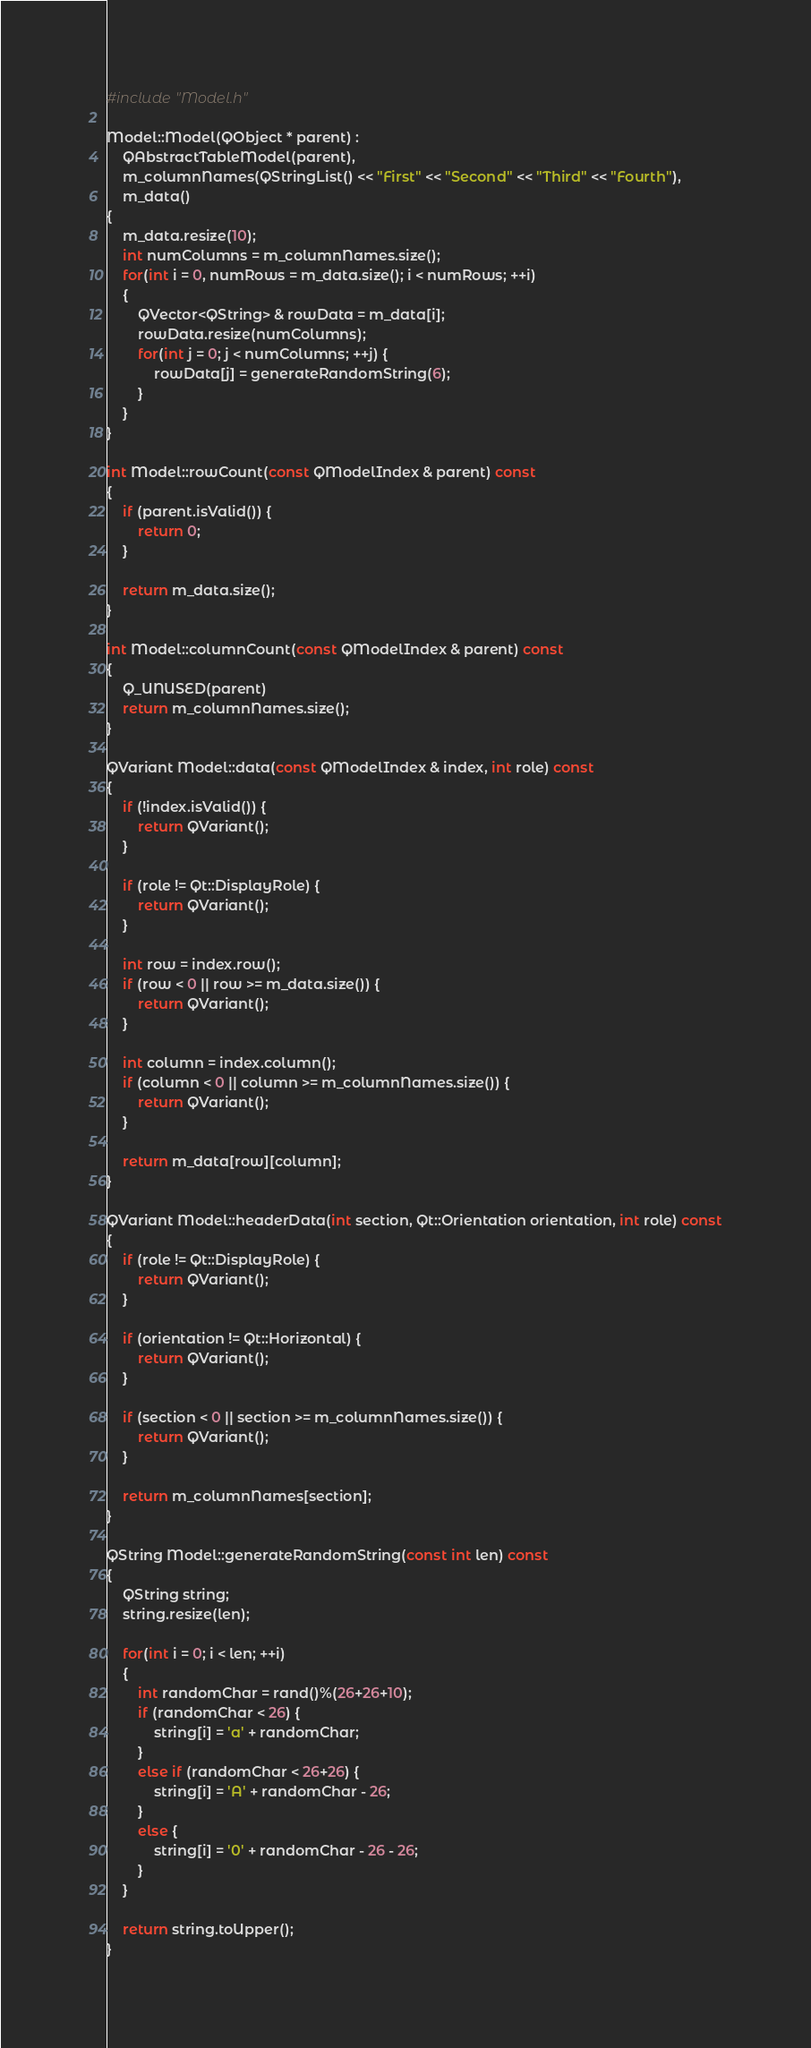<code> <loc_0><loc_0><loc_500><loc_500><_C++_>#include "Model.h"

Model::Model(QObject * parent) :
    QAbstractTableModel(parent),
    m_columnNames(QStringList() << "First" << "Second" << "Third" << "Fourth"),
    m_data()
{
    m_data.resize(10);
    int numColumns = m_columnNames.size();
    for(int i = 0, numRows = m_data.size(); i < numRows; ++i)
    {
        QVector<QString> & rowData = m_data[i];
        rowData.resize(numColumns);
        for(int j = 0; j < numColumns; ++j) {
            rowData[j] = generateRandomString(6);
        }
    }
}

int Model::rowCount(const QModelIndex & parent) const
{
    if (parent.isValid()) {
        return 0;
    }

    return m_data.size();
}

int Model::columnCount(const QModelIndex & parent) const
{
    Q_UNUSED(parent)
    return m_columnNames.size();
}

QVariant Model::data(const QModelIndex & index, int role) const
{
    if (!index.isValid()) {
        return QVariant();
    }

    if (role != Qt::DisplayRole) {
        return QVariant();
    }

    int row = index.row();
    if (row < 0 || row >= m_data.size()) {
        return QVariant();
    }

    int column = index.column();
    if (column < 0 || column >= m_columnNames.size()) {
        return QVariant();
    }

    return m_data[row][column];
}

QVariant Model::headerData(int section, Qt::Orientation orientation, int role) const
{
    if (role != Qt::DisplayRole) {
        return QVariant();
    }

    if (orientation != Qt::Horizontal) {
        return QVariant();
    }

    if (section < 0 || section >= m_columnNames.size()) {
        return QVariant();
    }

    return m_columnNames[section];
}

QString Model::generateRandomString(const int len) const
{
    QString string;
    string.resize(len);

    for(int i = 0; i < len; ++i)
    {
        int randomChar = rand()%(26+26+10);
        if (randomChar < 26) {
            string[i] = 'a' + randomChar;
        }
        else if (randomChar < 26+26) {
            string[i] = 'A' + randomChar - 26;
        }
        else {
            string[i] = '0' + randomChar - 26 - 26;
        }
    }

    return string.toUpper();
}


</code> 